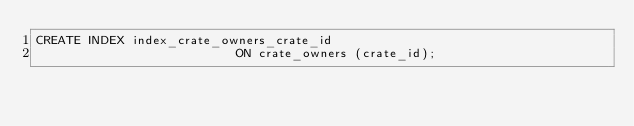Convert code to text. <code><loc_0><loc_0><loc_500><loc_500><_SQL_>CREATE INDEX index_crate_owners_crate_id
                           ON crate_owners (crate_id);</code> 